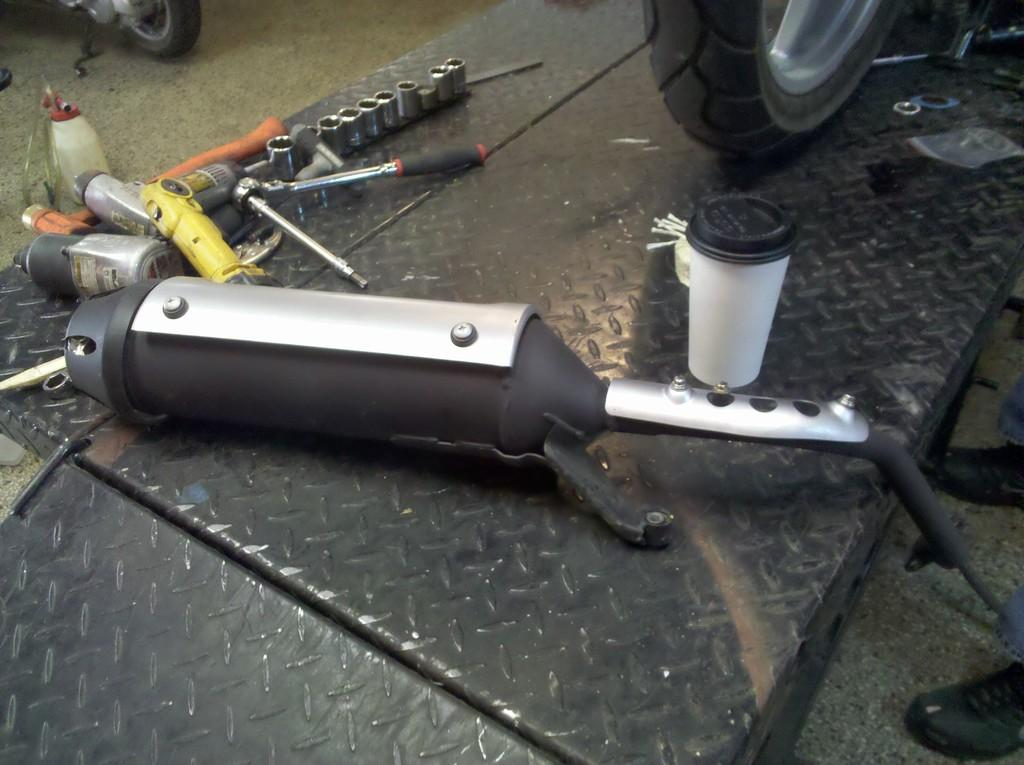What type of object is made of metal in the image? There is a metal object in the image, but its specific type is not mentioned. What else can be seen in the image besides the metal object? There are tools visible in the image. Can you describe the person on the right side of the image? The provided facts do not give any details about the person's appearance or actions. What can be seen in the background of the image? There are vehicles visible in the background of the image. What type of ornament is hanging from the stem in the image? There is no ornament or stem present in the image. Can you describe the picture on the wall in the image? There is no mention of a picture or wall in the provided facts. 